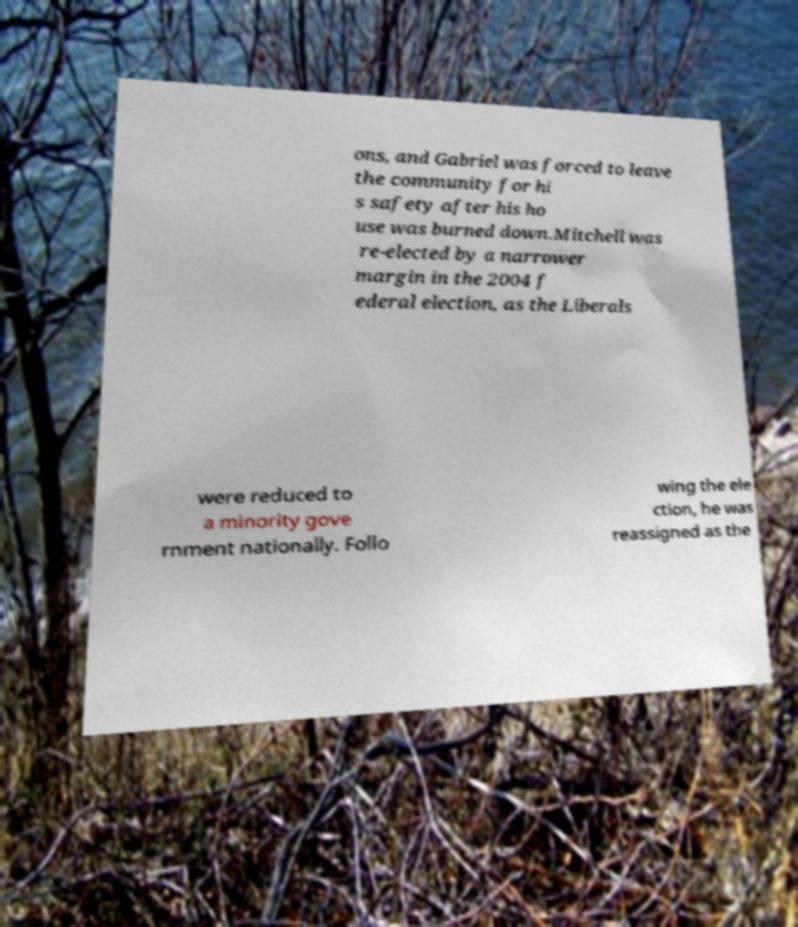Could you assist in decoding the text presented in this image and type it out clearly? ons, and Gabriel was forced to leave the community for hi s safety after his ho use was burned down.Mitchell was re-elected by a narrower margin in the 2004 f ederal election, as the Liberals were reduced to a minority gove rnment nationally. Follo wing the ele ction, he was reassigned as the 